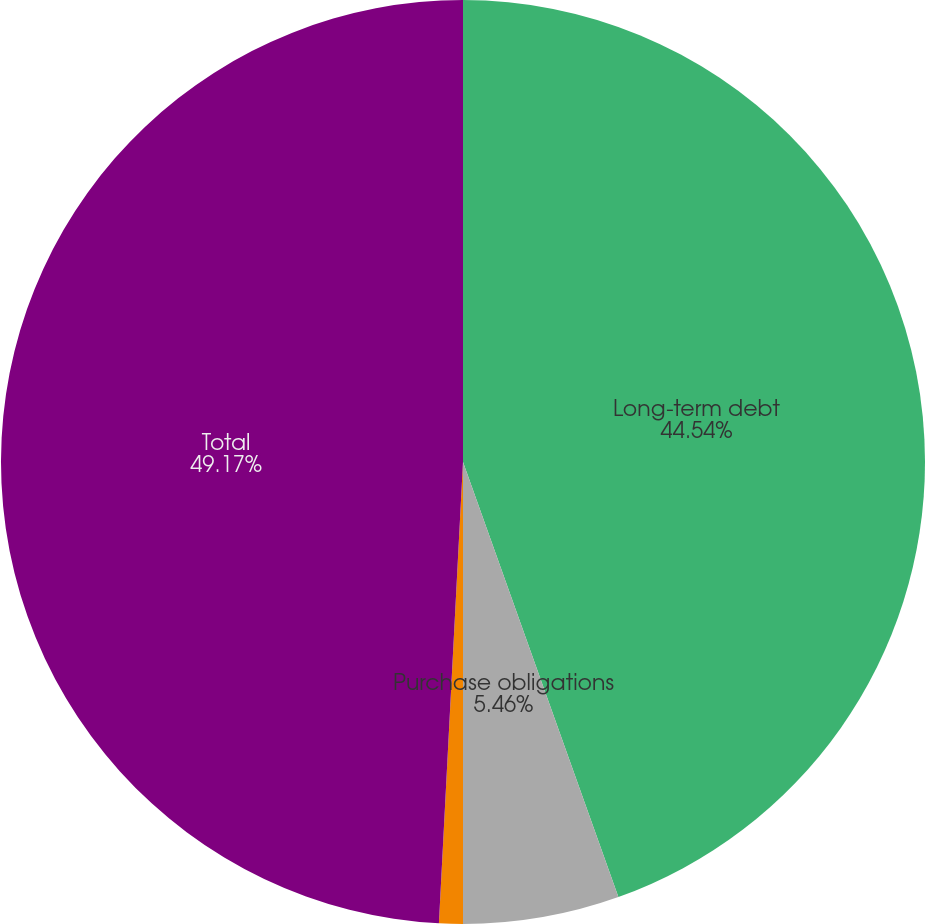Convert chart. <chart><loc_0><loc_0><loc_500><loc_500><pie_chart><fcel>Long-term debt<fcel>Purchase obligations<fcel>Operating lease<fcel>Total<nl><fcel>44.54%<fcel>5.46%<fcel>0.83%<fcel>49.17%<nl></chart> 